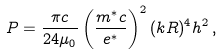<formula> <loc_0><loc_0><loc_500><loc_500>P = \frac { \pi c } { 2 4 \mu _ { 0 } } \left ( \frac { m ^ { \ast } c } { e ^ { \ast } } \right ) ^ { 2 } ( k R ) ^ { 4 } h ^ { 2 } \, ,</formula> 